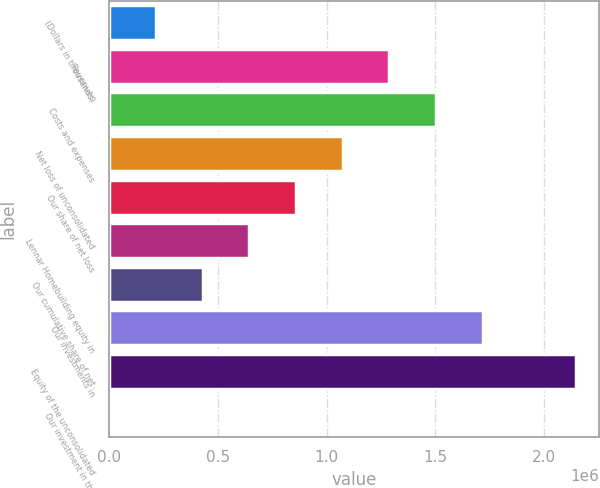<chart> <loc_0><loc_0><loc_500><loc_500><bar_chart><fcel>(Dollars in thousands)<fcel>Revenues<fcel>Costs and expenses<fcel>Net loss of unconsolidated<fcel>Our share of net loss<fcel>Lennar Homebuilding equity in<fcel>Our cumulative share of net<fcel>Our investments in<fcel>Equity of the unconsolidated<fcel>Our investment in the<nl><fcel>214887<fcel>1.28918e+06<fcel>1.50404e+06<fcel>1.07432e+06<fcel>859461<fcel>644603<fcel>429745<fcel>1.71889e+06<fcel>2.14861e+06<fcel>29<nl></chart> 